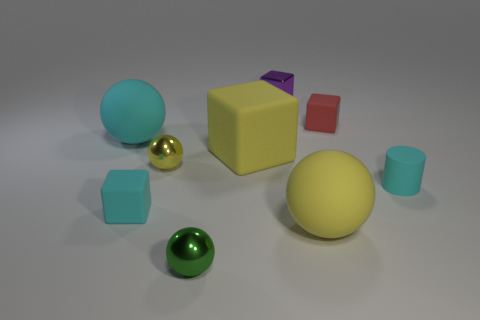Is the number of tiny purple shiny objects to the left of the tiny metal block the same as the number of tiny metallic cubes?
Provide a succinct answer. No. What size is the object to the right of the small red object?
Offer a terse response. Small. What number of small things are either red things or cyan matte cylinders?
Provide a short and direct response. 2. What is the color of the large object that is the same shape as the small purple thing?
Your answer should be compact. Yellow. Do the purple metal object and the red rubber thing have the same size?
Your answer should be compact. Yes. How many things are small cyan matte cylinders or large cyan objects that are in front of the shiny block?
Your answer should be compact. 2. There is a cube in front of the small cyan rubber thing right of the yellow matte cube; what is its color?
Give a very brief answer. Cyan. Do the object to the right of the tiny red rubber block and the large cube have the same color?
Provide a short and direct response. No. What is the large ball that is to the left of the small green object made of?
Your answer should be very brief. Rubber. What is the size of the green shiny thing?
Offer a terse response. Small. 